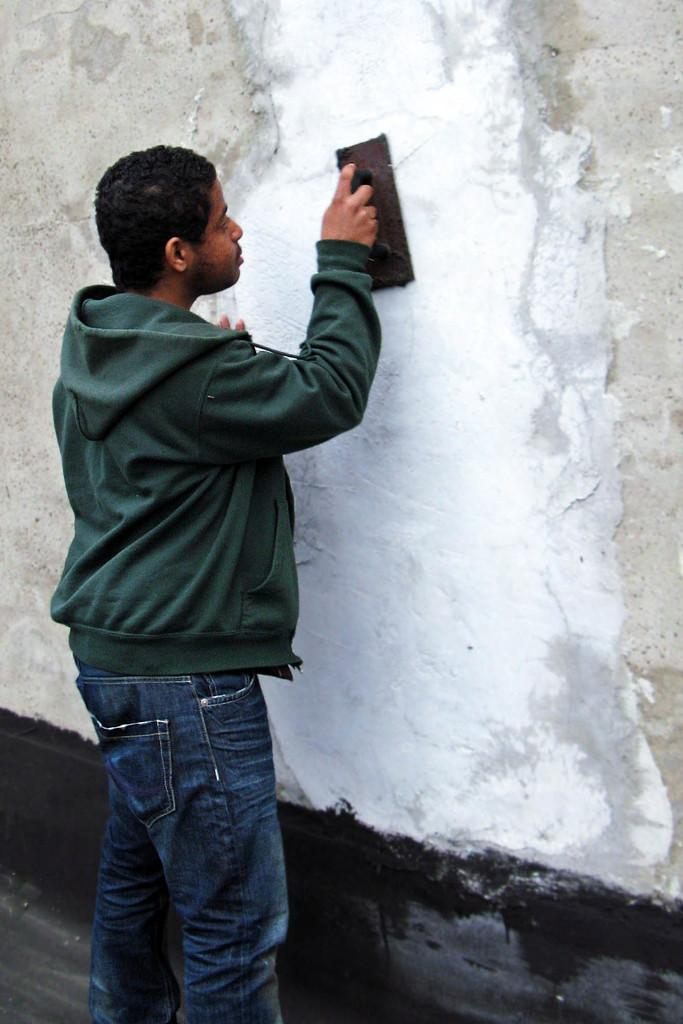Who is present in the image? There is a man in the image. What is the man wearing? The man is wearing a jacket. What is the man holding in his hand? The man is holding an object in his hand. What direction is the man facing? The man is facing towards a wall. What activity is the man engaged in? It appears that the man is painting the wall. How many trains can be seen in the image? There are no trains present in the image. What force is being applied by the man in the image? There is no information about any force being applied by the man in the image. 